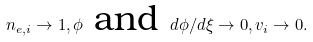Convert formula to latex. <formula><loc_0><loc_0><loc_500><loc_500>n _ { e , i } \rightarrow 1 , \phi \ \text {and} \ d \phi / d \xi \rightarrow 0 , v _ { i } \rightarrow 0 .</formula> 